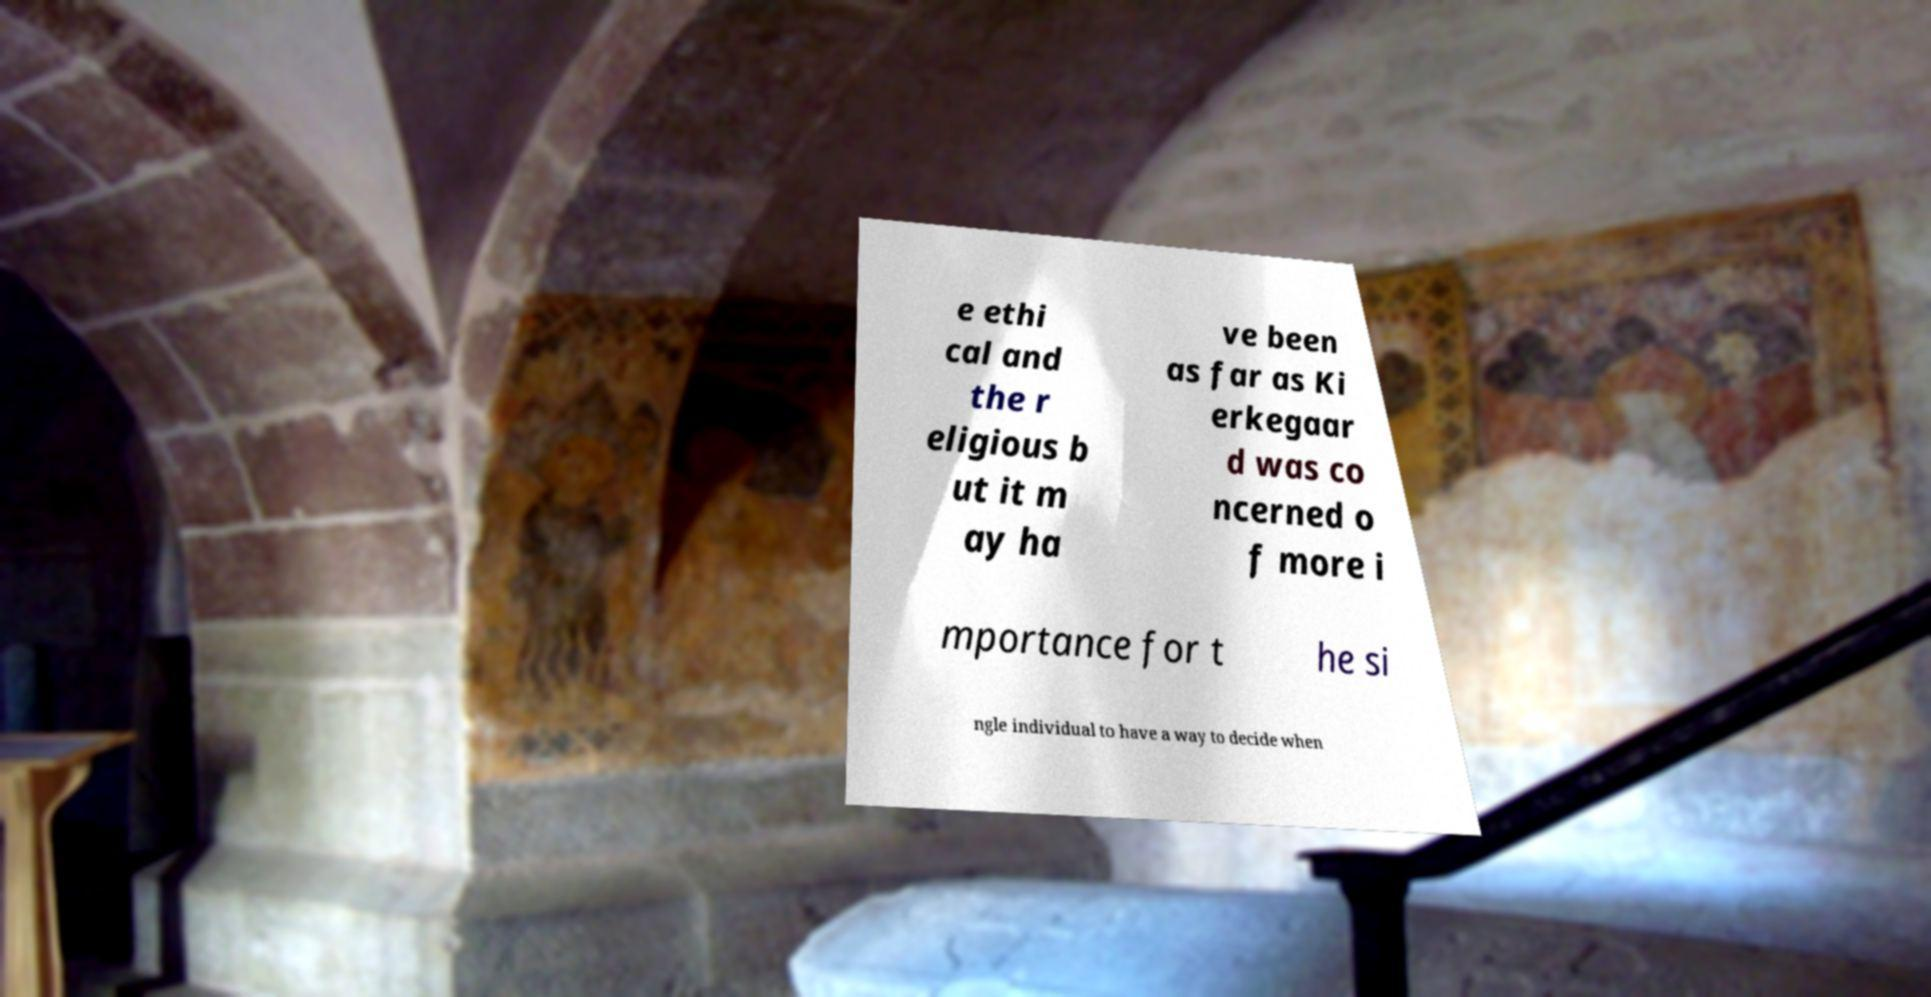I need the written content from this picture converted into text. Can you do that? e ethi cal and the r eligious b ut it m ay ha ve been as far as Ki erkegaar d was co ncerned o f more i mportance for t he si ngle individual to have a way to decide when 